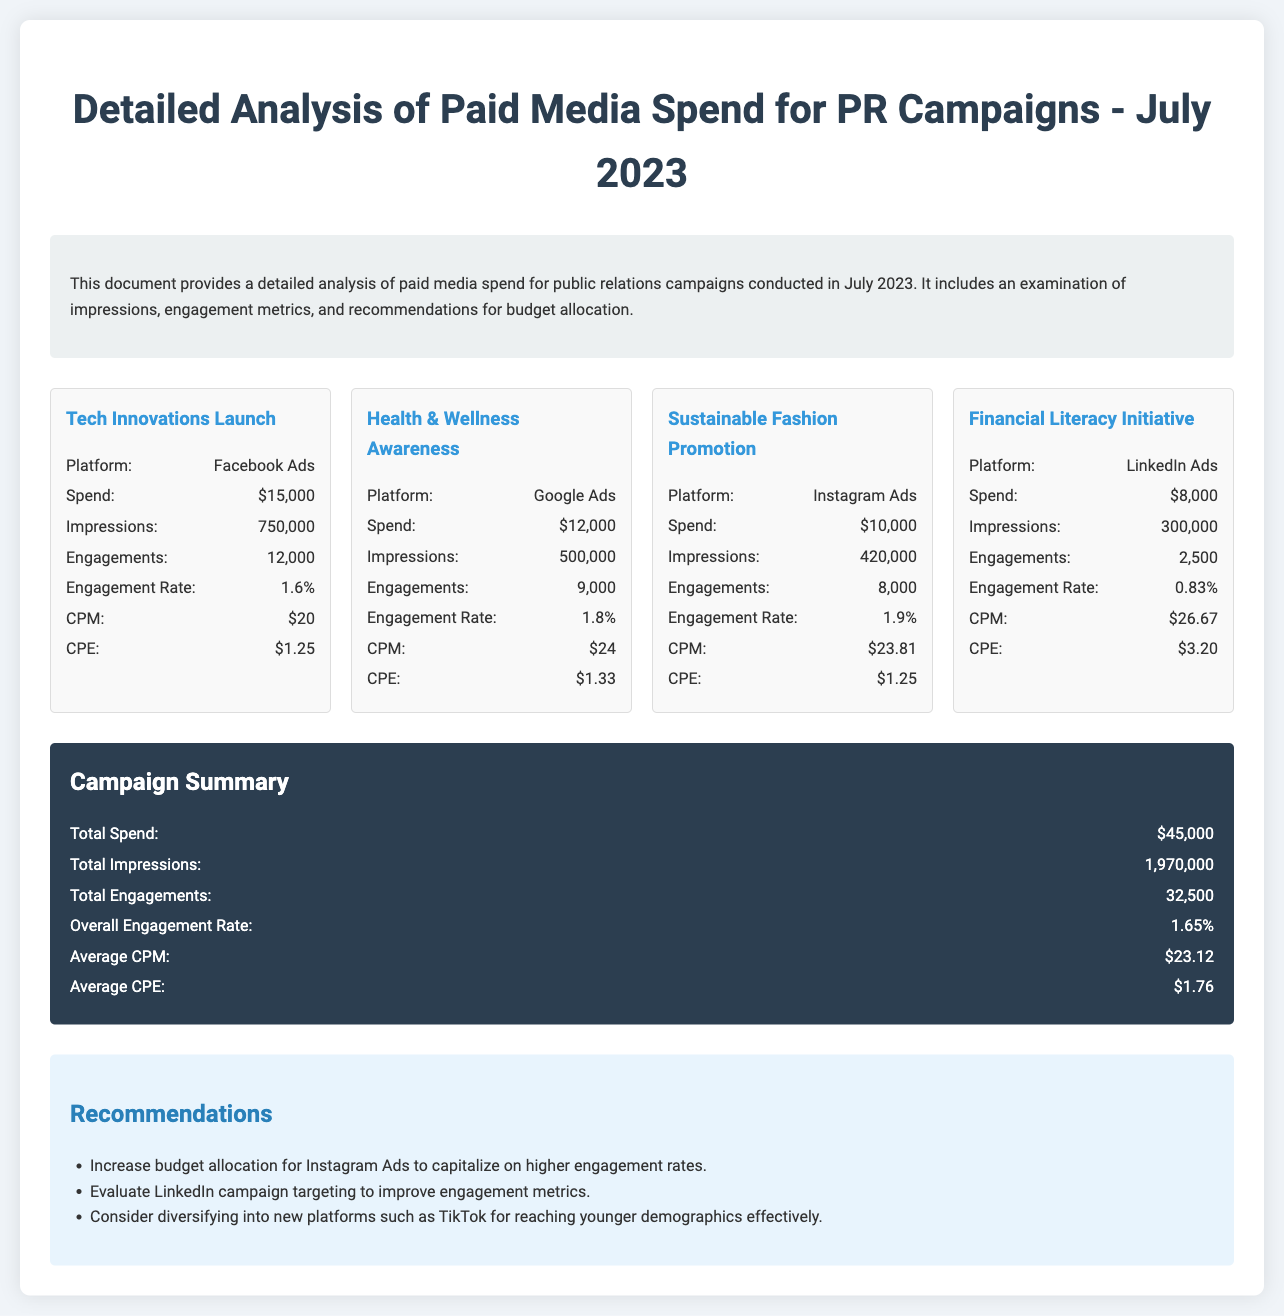What was the total spend for all campaigns? The total spend is the sum of all campaign spends listed in the document, which is calculated as $15,000 + $12,000 + $10,000 + $8,000 = $45,000.
Answer: $45,000 Which campaign had the highest engagement rate? The engagement rates for each campaign are given, and the highest engagement rate is 1.9% from the Sustainable Fashion Promotion campaign.
Answer: 1.9% What platform was used for the Financial Literacy Initiative campaign? The document specifies that LinkedIn Ads were used for the Financial Literacy Initiative campaign.
Answer: LinkedIn Ads How many total impressions were generated across all campaigns? The total impressions are provided in the summary section of the document, totaling 1,970,000 impressions.
Answer: 1,970,000 What was the engagement rate for the Tech Innovations Launch campaign? The engagement rate for the Tech Innovations Launch campaign is specified as 1.6% in the document.
Answer: 1.6% What is the average Cost Per Engagement (CPE) across all campaigns? The document summarizes the average CPE as $1.76, which is calculated from individual campaign CPE values.
Answer: $1.76 Which campaign had the lowest spend? The campaign spend data shows that the Financial Literacy Initiative had the lowest spend of $8,000.
Answer: $8,000 What is the total number of engagements for the Health & Wellness Awareness campaign? The document states that the total engagements for the Health & Wellness Awareness campaign are 9,000.
Answer: 9,000 What recommendation is given for LinkedIn campaigns? The document suggests evaluating LinkedIn campaign targeting to improve engagement metrics.
Answer: Evaluate LinkedIn campaign targeting to improve engagement metrics 